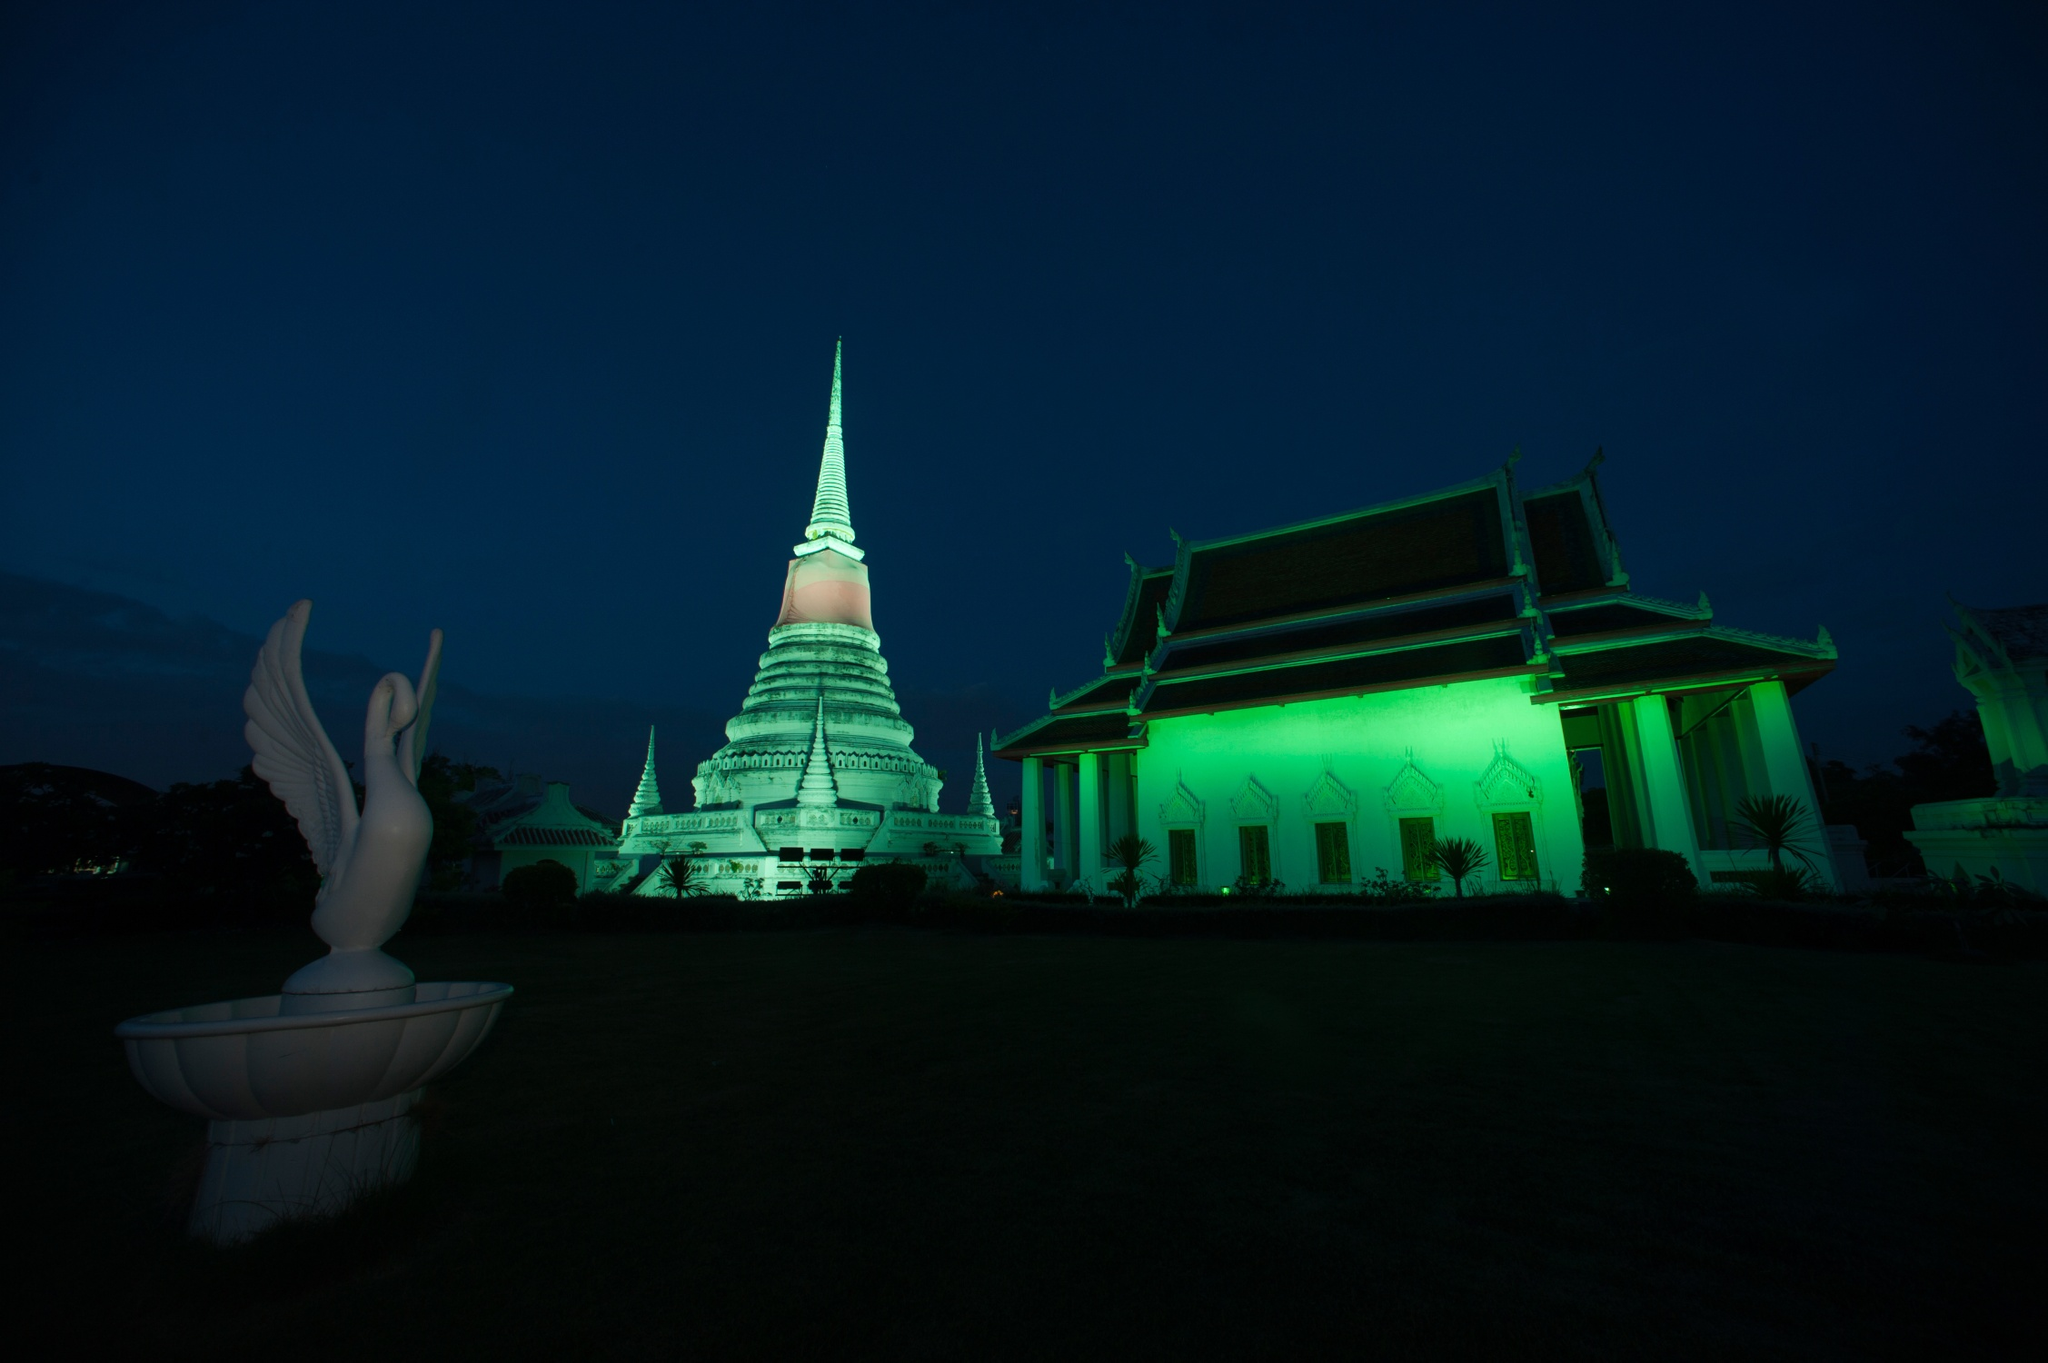Can you describe the atmosphere of the image? The atmosphere of the image is tranquil and mystical. The deep blue sky and the green illumination on the temple create a serene yet otherworldly ambiance. The well-lit temple and the bird sculpture stand out dramatically against the dark backdrop, giving a sense of reverence and calm. 